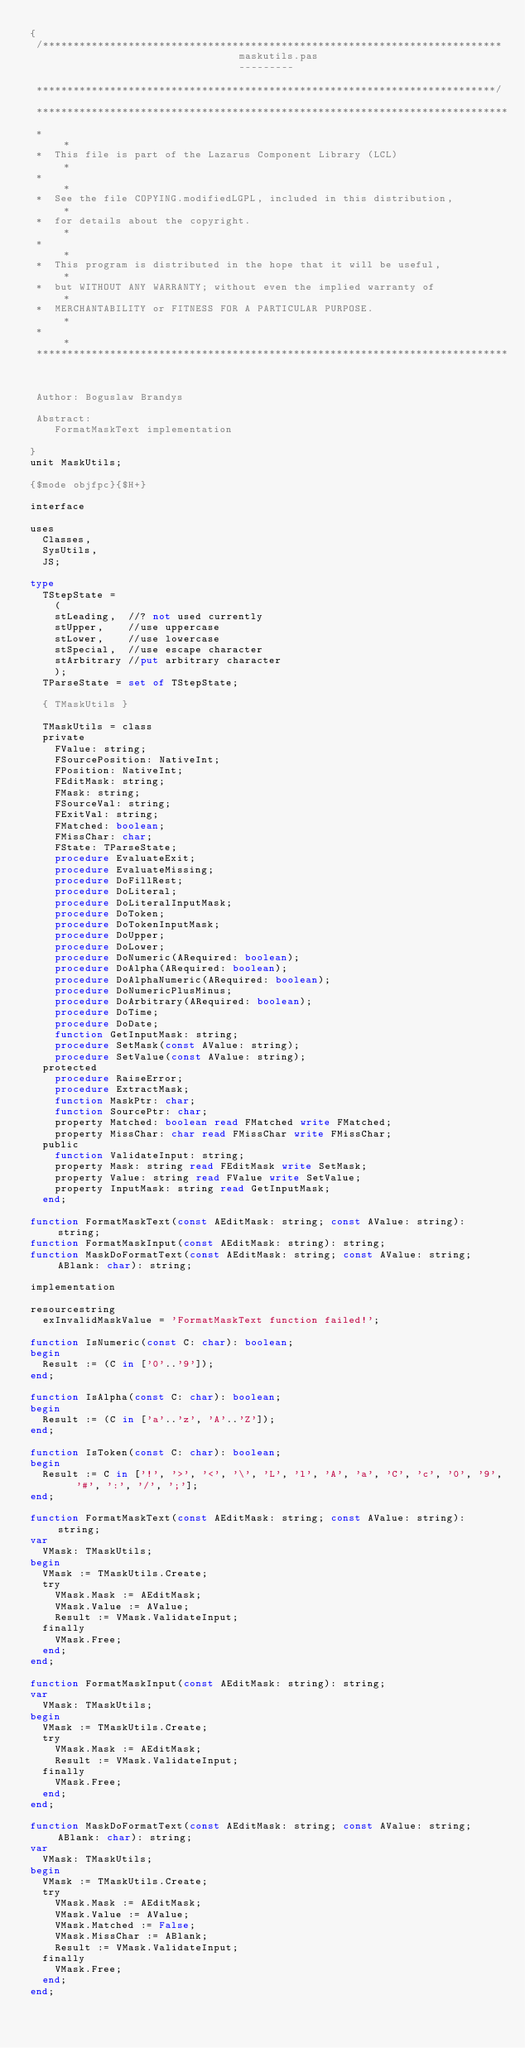<code> <loc_0><loc_0><loc_500><loc_500><_Pascal_>{
 /***************************************************************************
                                  maskutils.pas
                                  ---------

 ***************************************************************************/

 *****************************************************************************
 *                                                                           *
 *  This file is part of the Lazarus Component Library (LCL)                 *
 *                                                                           *
 *  See the file COPYING.modifiedLGPL, included in this distribution,        *
 *  for details about the copyright.                                         *
 *                                                                           *
 *  This program is distributed in the hope that it will be useful,          *
 *  but WITHOUT ANY WARRANTY; without even the implied warranty of           *
 *  MERCHANTABILITY or FITNESS FOR A PARTICULAR PURPOSE.                     *
 *                                                                           *
 *****************************************************************************


 Author: Boguslaw Brandys

 Abstract:
    FormatMaskText implementation

}
unit MaskUtils;

{$mode objfpc}{$H+}

interface

uses
  Classes,
  SysUtils,
  JS;

type
  TStepState =
    (
    stLeading,  //? not used currently
    stUpper,    //use uppercase
    stLower,    //use lowercase
    stSpecial,  //use escape character
    stArbitrary //put arbitrary character
    );
  TParseState = set of TStepState;

  { TMaskUtils }

  TMaskUtils = class
  private
    FValue: string;
    FSourcePosition: NativeInt;
    FPosition: NativeInt;
    FEditMask: string;
    FMask: string;
    FSourceVal: string;
    FExitVal: string;
    FMatched: boolean;
    FMissChar: char;
    FState: TParseState;
    procedure EvaluateExit;
    procedure EvaluateMissing;
    procedure DoFillRest;
    procedure DoLiteral;
    procedure DoLiteralInputMask;
    procedure DoToken;
    procedure DoTokenInputMask;
    procedure DoUpper;
    procedure DoLower;
    procedure DoNumeric(ARequired: boolean);
    procedure DoAlpha(ARequired: boolean);
    procedure DoAlphaNumeric(ARequired: boolean);
    procedure DoNumericPlusMinus;
    procedure DoArbitrary(ARequired: boolean);
    procedure DoTime;
    procedure DoDate;
    function GetInputMask: string;
    procedure SetMask(const AValue: string);
    procedure SetValue(const AValue: string);
  protected
    procedure RaiseError;
    procedure ExtractMask;
    function MaskPtr: char;
    function SourcePtr: char;
    property Matched: boolean read FMatched write FMatched;
    property MissChar: char read FMissChar write FMissChar;
  public
    function ValidateInput: string;
    property Mask: string read FEditMask write SetMask;
    property Value: string read FValue write SetValue;
    property InputMask: string read GetInputMask;
  end;

function FormatMaskText(const AEditMask: string; const AValue: string): string;
function FormatMaskInput(const AEditMask: string): string;
function MaskDoFormatText(const AEditMask: string; const AValue: string; ABlank: char): string;

implementation

resourcestring
  exInvalidMaskValue = 'FormatMaskText function failed!';

function IsNumeric(const C: char): boolean;
begin
  Result := (C in ['0'..'9']);
end;

function IsAlpha(const C: char): boolean;
begin
  Result := (C in ['a'..'z', 'A'..'Z']);
end;

function IsToken(const C: char): boolean;
begin
  Result := C in ['!', '>', '<', '\', 'L', 'l', 'A', 'a', 'C', 'c', '0', '9', '#', ':', '/', ';'];
end;

function FormatMaskText(const AEditMask: string; const AValue: string): string;
var
  VMask: TMaskUtils;
begin
  VMask := TMaskUtils.Create;
  try
    VMask.Mask := AEditMask;
    VMask.Value := AValue;
    Result := VMask.ValidateInput;
  finally
    VMask.Free;
  end;
end;

function FormatMaskInput(const AEditMask: string): string;
var
  VMask: TMaskUtils;
begin
  VMask := TMaskUtils.Create;
  try
    VMask.Mask := AEditMask;
    Result := VMask.ValidateInput;
  finally
    VMask.Free;
  end;
end;

function MaskDoFormatText(const AEditMask: string; const AValue: string; ABlank: char): string;
var
  VMask: TMaskUtils;
begin
  VMask := TMaskUtils.Create;
  try
    VMask.Mask := AEditMask;
    VMask.Value := AValue;
    VMask.Matched := False;
    VMask.MissChar := ABlank;
    Result := VMask.ValidateInput;
  finally
    VMask.Free;
  end;
end;
</code> 